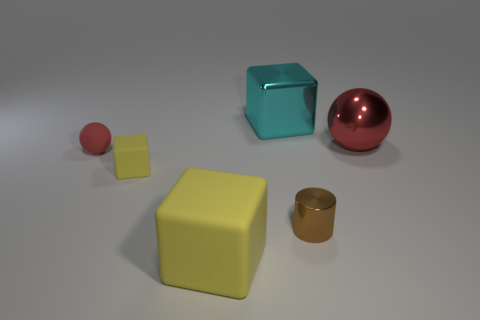Add 1 tiny red balls. How many objects exist? 7 Subtract all balls. How many objects are left? 4 Add 3 rubber spheres. How many rubber spheres are left? 4 Add 6 cyan blocks. How many cyan blocks exist? 7 Subtract 0 red cylinders. How many objects are left? 6 Subtract all small purple cubes. Subtract all red objects. How many objects are left? 4 